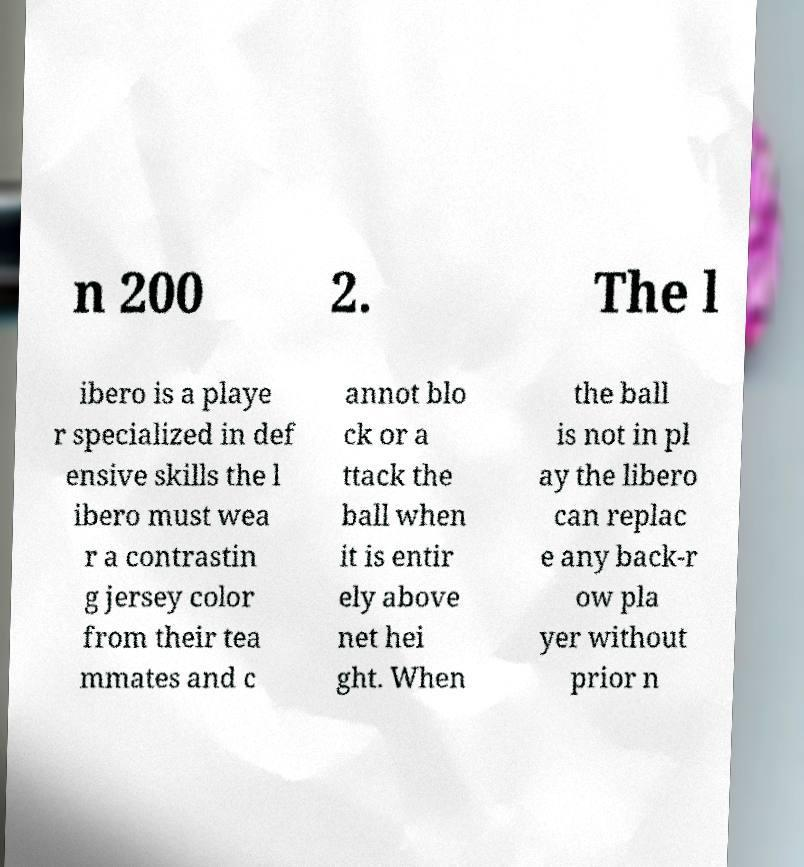Can you accurately transcribe the text from the provided image for me? n 200 2. The l ibero is a playe r specialized in def ensive skills the l ibero must wea r a contrastin g jersey color from their tea mmates and c annot blo ck or a ttack the ball when it is entir ely above net hei ght. When the ball is not in pl ay the libero can replac e any back-r ow pla yer without prior n 